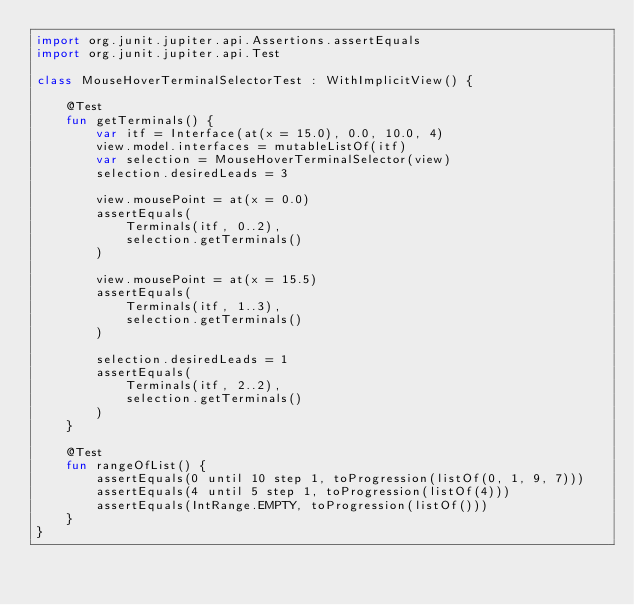Convert code to text. <code><loc_0><loc_0><loc_500><loc_500><_Kotlin_>import org.junit.jupiter.api.Assertions.assertEquals
import org.junit.jupiter.api.Test

class MouseHoverTerminalSelectorTest : WithImplicitView() {

    @Test
    fun getTerminals() {
        var itf = Interface(at(x = 15.0), 0.0, 10.0, 4)
        view.model.interfaces = mutableListOf(itf)
        var selection = MouseHoverTerminalSelector(view)
        selection.desiredLeads = 3

        view.mousePoint = at(x = 0.0)
        assertEquals(
            Terminals(itf, 0..2),
            selection.getTerminals()
        )

        view.mousePoint = at(x = 15.5)
        assertEquals(
            Terminals(itf, 1..3),
            selection.getTerminals()
        )

        selection.desiredLeads = 1
        assertEquals(
            Terminals(itf, 2..2),
            selection.getTerminals()
        )
    }

    @Test
    fun rangeOfList() {
        assertEquals(0 until 10 step 1, toProgression(listOf(0, 1, 9, 7)))
        assertEquals(4 until 5 step 1, toProgression(listOf(4)))
        assertEquals(IntRange.EMPTY, toProgression(listOf()))
    }
}
</code> 